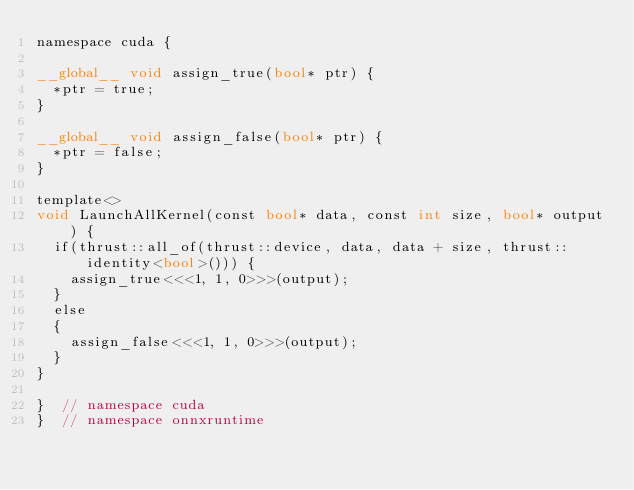Convert code to text. <code><loc_0><loc_0><loc_500><loc_500><_Cuda_>namespace cuda {

__global__ void assign_true(bool* ptr) {
  *ptr = true;
}

__global__ void assign_false(bool* ptr) {
  *ptr = false;
}

template<>
void LaunchAllKernel(const bool* data, const int size, bool* output) {
  if(thrust::all_of(thrust::device, data, data + size, thrust::identity<bool>())) {
    assign_true<<<1, 1, 0>>>(output);
  }
  else
  {
    assign_false<<<1, 1, 0>>>(output);
  }
}

}  // namespace cuda
}  // namespace onnxruntime
</code> 